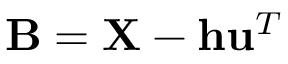<formula> <loc_0><loc_0><loc_500><loc_500>B = X - h u ^ { T }</formula> 